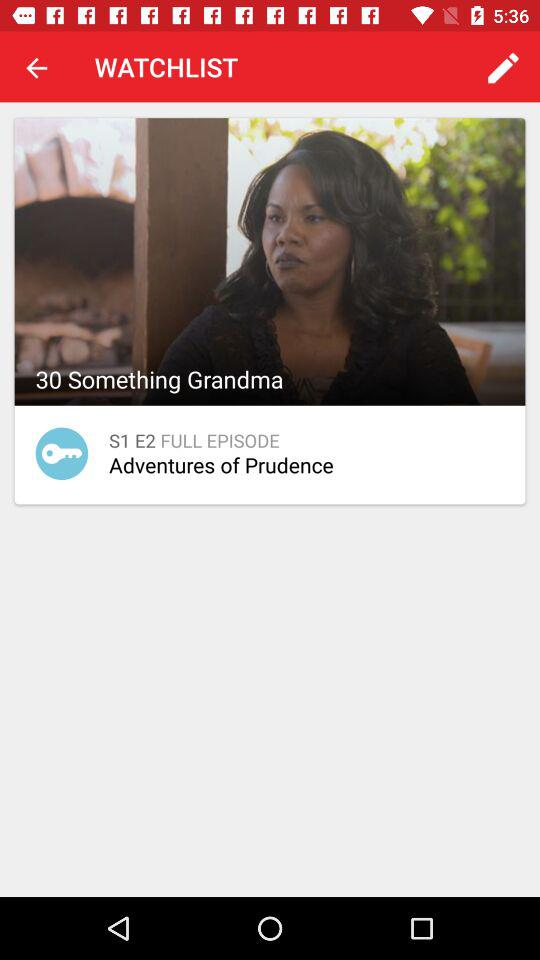What is the episode name? The episode name is "Adventures of Prudence". 